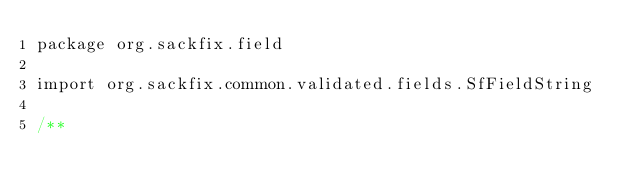<code> <loc_0><loc_0><loc_500><loc_500><_Scala_>package org.sackfix.field

import org.sackfix.common.validated.fields.SfFieldString

/**</code> 